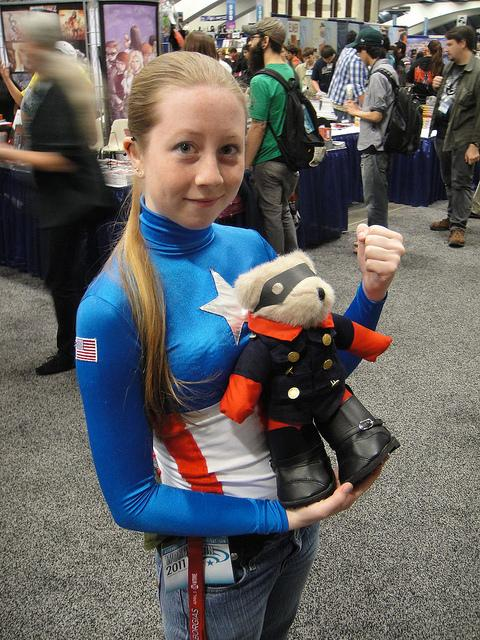In which sort of event does this woman pose? Please explain your reasoning. expo. The woman is dressed in a costume at an expo or convention center. 